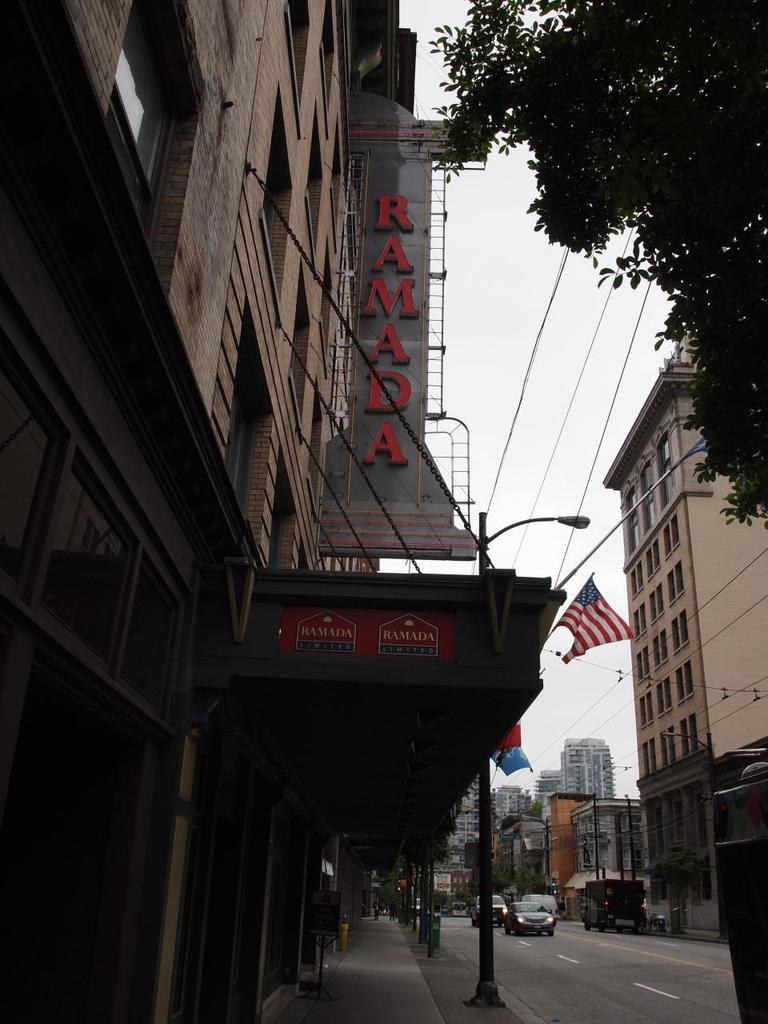What type of structures can be seen in the image? There are buildings in the image. What other natural elements are present in the image? There are trees in the image. What can be seen in the background of the image? The sky is visible in the image. What mode of transportation can be seen on the road in the image? There are vehicles on the road in the image. What type of bun is being used to hold the grain in the image? There is no bun or grain present in the image. How fast are the people running in the image? There are no people running in the image; it features buildings, trees, the sky, and vehicles on the road. 